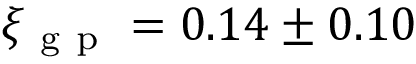Convert formula to latex. <formula><loc_0><loc_0><loc_500><loc_500>\xi _ { g p } = 0 . 1 4 \pm 0 . 1 0</formula> 